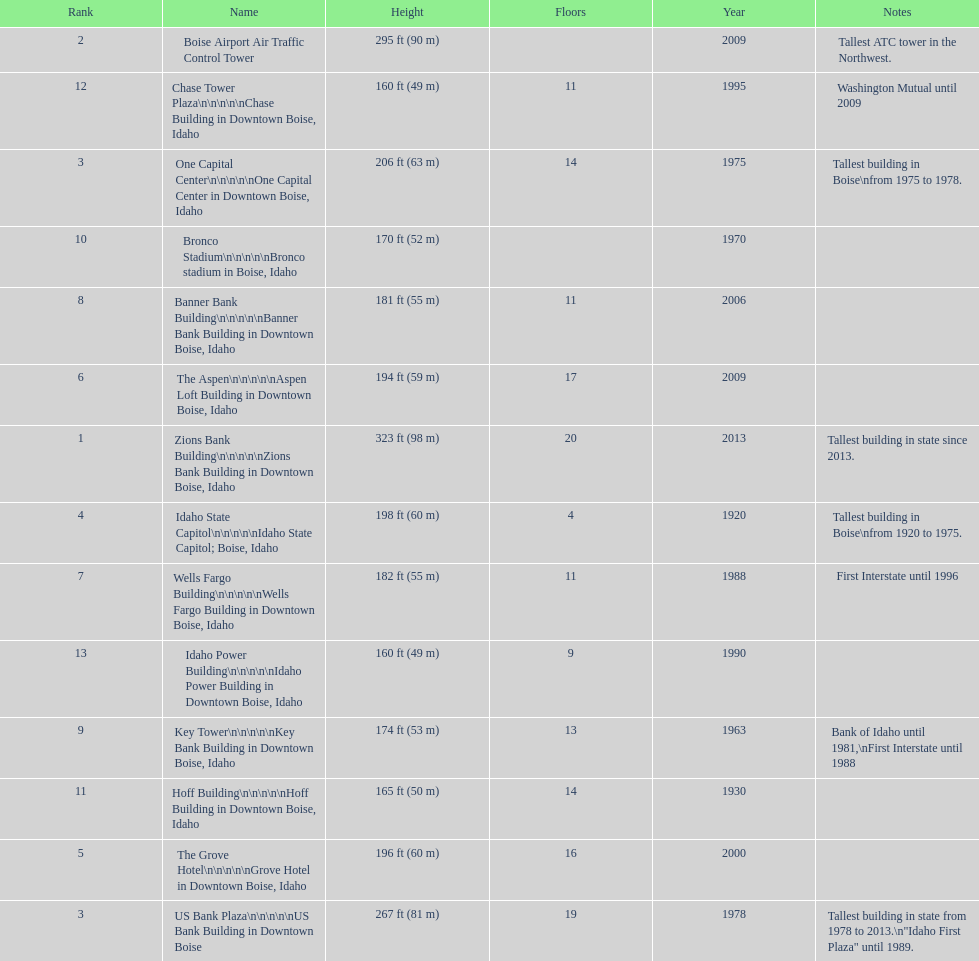How many of these buildings were built after 1975 8. 